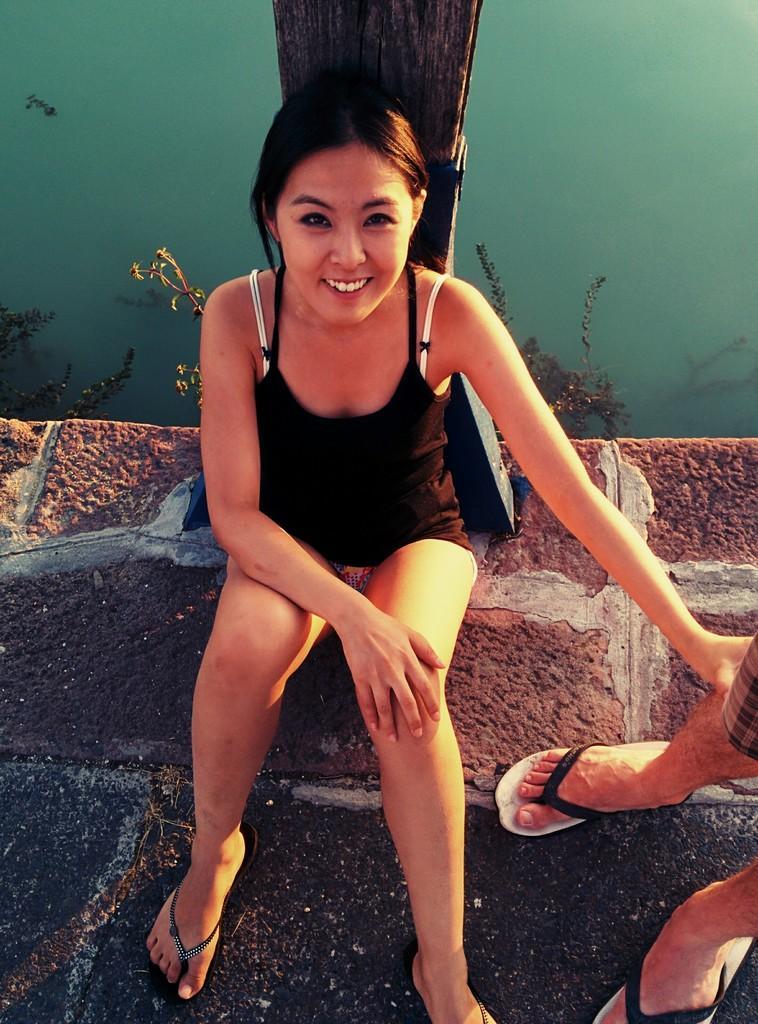Describe this image in one or two sentences. In this image we can see a lady person wearing black color dress sitting and we can see a person's legs and in the background of the image we can see blue color wall and wooden block. 